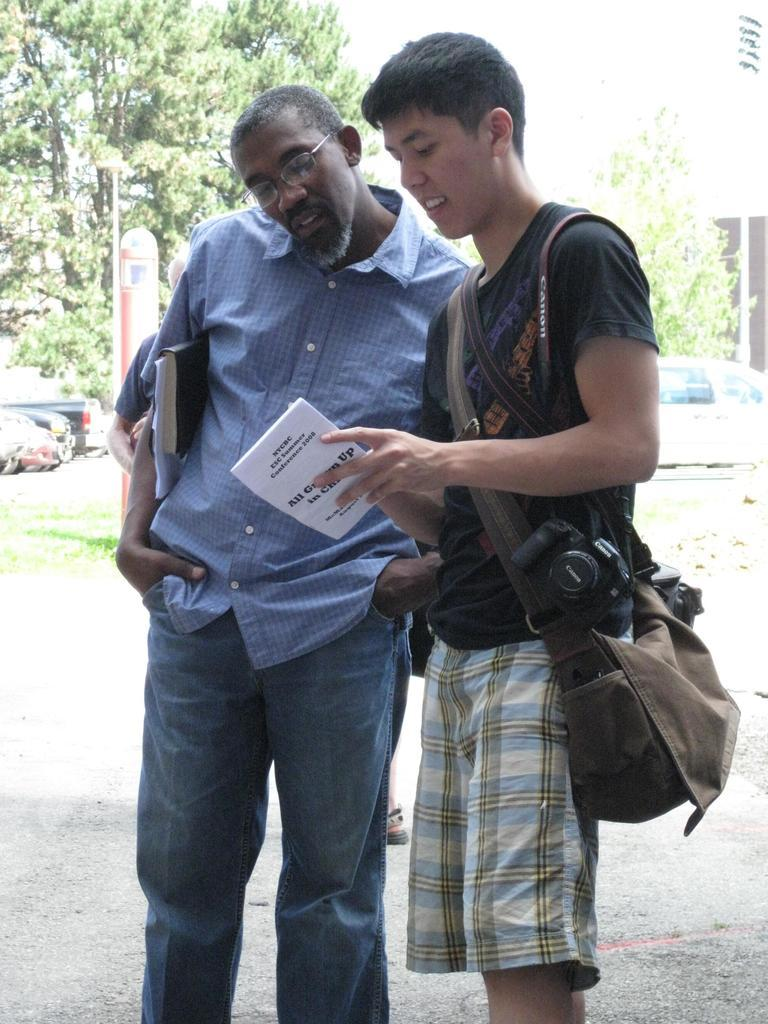What are the men in the image holding? The men are holding books, a camera, and a bag. What can be seen in the background of the image? There are buildings, trees, motor vehicles, and grass in the background of the image. What type of crime is being committed in the image? There is no indication of any crime being committed in the image. How does the wind affect the men in the image? There is no mention of wind in the image, so its effect on the men cannot be determined. 